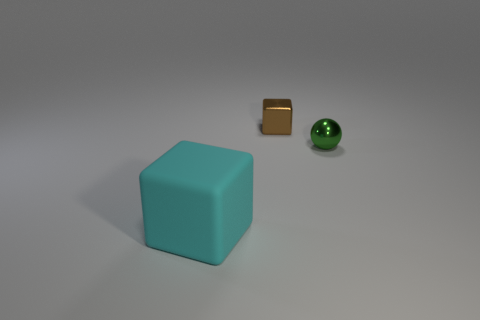Subtract all brown blocks. How many blocks are left? 1 Add 3 tiny blue rubber cylinders. How many objects exist? 6 Subtract 1 cubes. How many cubes are left? 1 Subtract 1 brown blocks. How many objects are left? 2 Subtract all balls. How many objects are left? 2 Subtract all cyan blocks. Subtract all gray cylinders. How many blocks are left? 1 Subtract all red balls. How many gray cubes are left? 0 Subtract all green objects. Subtract all small purple spheres. How many objects are left? 2 Add 1 small metallic balls. How many small metallic balls are left? 2 Add 2 brown blocks. How many brown blocks exist? 3 